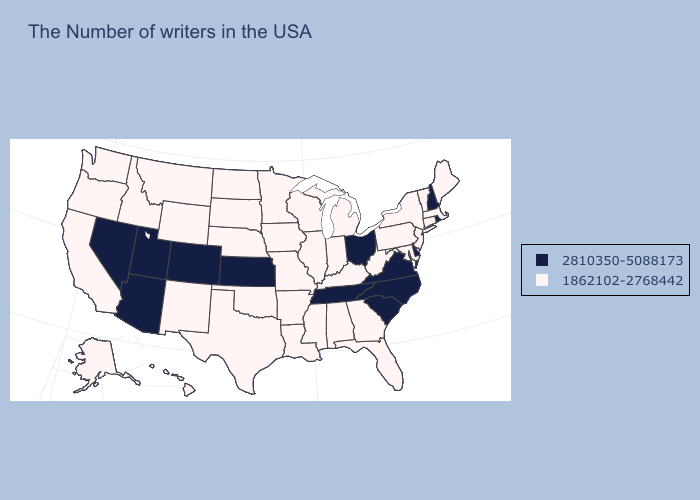Does Virginia have the lowest value in the USA?
Short answer required. No. Does the first symbol in the legend represent the smallest category?
Short answer required. No. Does the first symbol in the legend represent the smallest category?
Answer briefly. No. Name the states that have a value in the range 2810350-5088173?
Answer briefly. Rhode Island, New Hampshire, Delaware, Virginia, North Carolina, South Carolina, Ohio, Tennessee, Kansas, Colorado, Utah, Arizona, Nevada. What is the highest value in the MidWest ?
Write a very short answer. 2810350-5088173. Name the states that have a value in the range 2810350-5088173?
Be succinct. Rhode Island, New Hampshire, Delaware, Virginia, North Carolina, South Carolina, Ohio, Tennessee, Kansas, Colorado, Utah, Arizona, Nevada. Name the states that have a value in the range 2810350-5088173?
Short answer required. Rhode Island, New Hampshire, Delaware, Virginia, North Carolina, South Carolina, Ohio, Tennessee, Kansas, Colorado, Utah, Arizona, Nevada. How many symbols are there in the legend?
Be succinct. 2. Among the states that border Illinois , which have the lowest value?
Give a very brief answer. Kentucky, Indiana, Wisconsin, Missouri, Iowa. What is the value of New Mexico?
Be succinct. 1862102-2768442. What is the value of South Dakota?
Give a very brief answer. 1862102-2768442. Does Colorado have the lowest value in the USA?
Give a very brief answer. No. Name the states that have a value in the range 2810350-5088173?
Concise answer only. Rhode Island, New Hampshire, Delaware, Virginia, North Carolina, South Carolina, Ohio, Tennessee, Kansas, Colorado, Utah, Arizona, Nevada. 